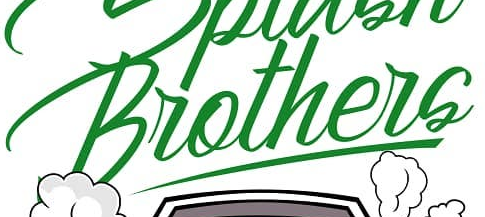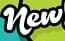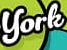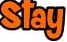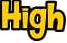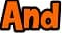What text appears in these images from left to right, separated by a semicolon? Brothers; New; York; Stay; High; And 